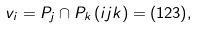Convert formula to latex. <formula><loc_0><loc_0><loc_500><loc_500>v _ { i } & = P _ { j } \cap P _ { k } \, ( i j k ) = ( 1 2 3 ) ,</formula> 